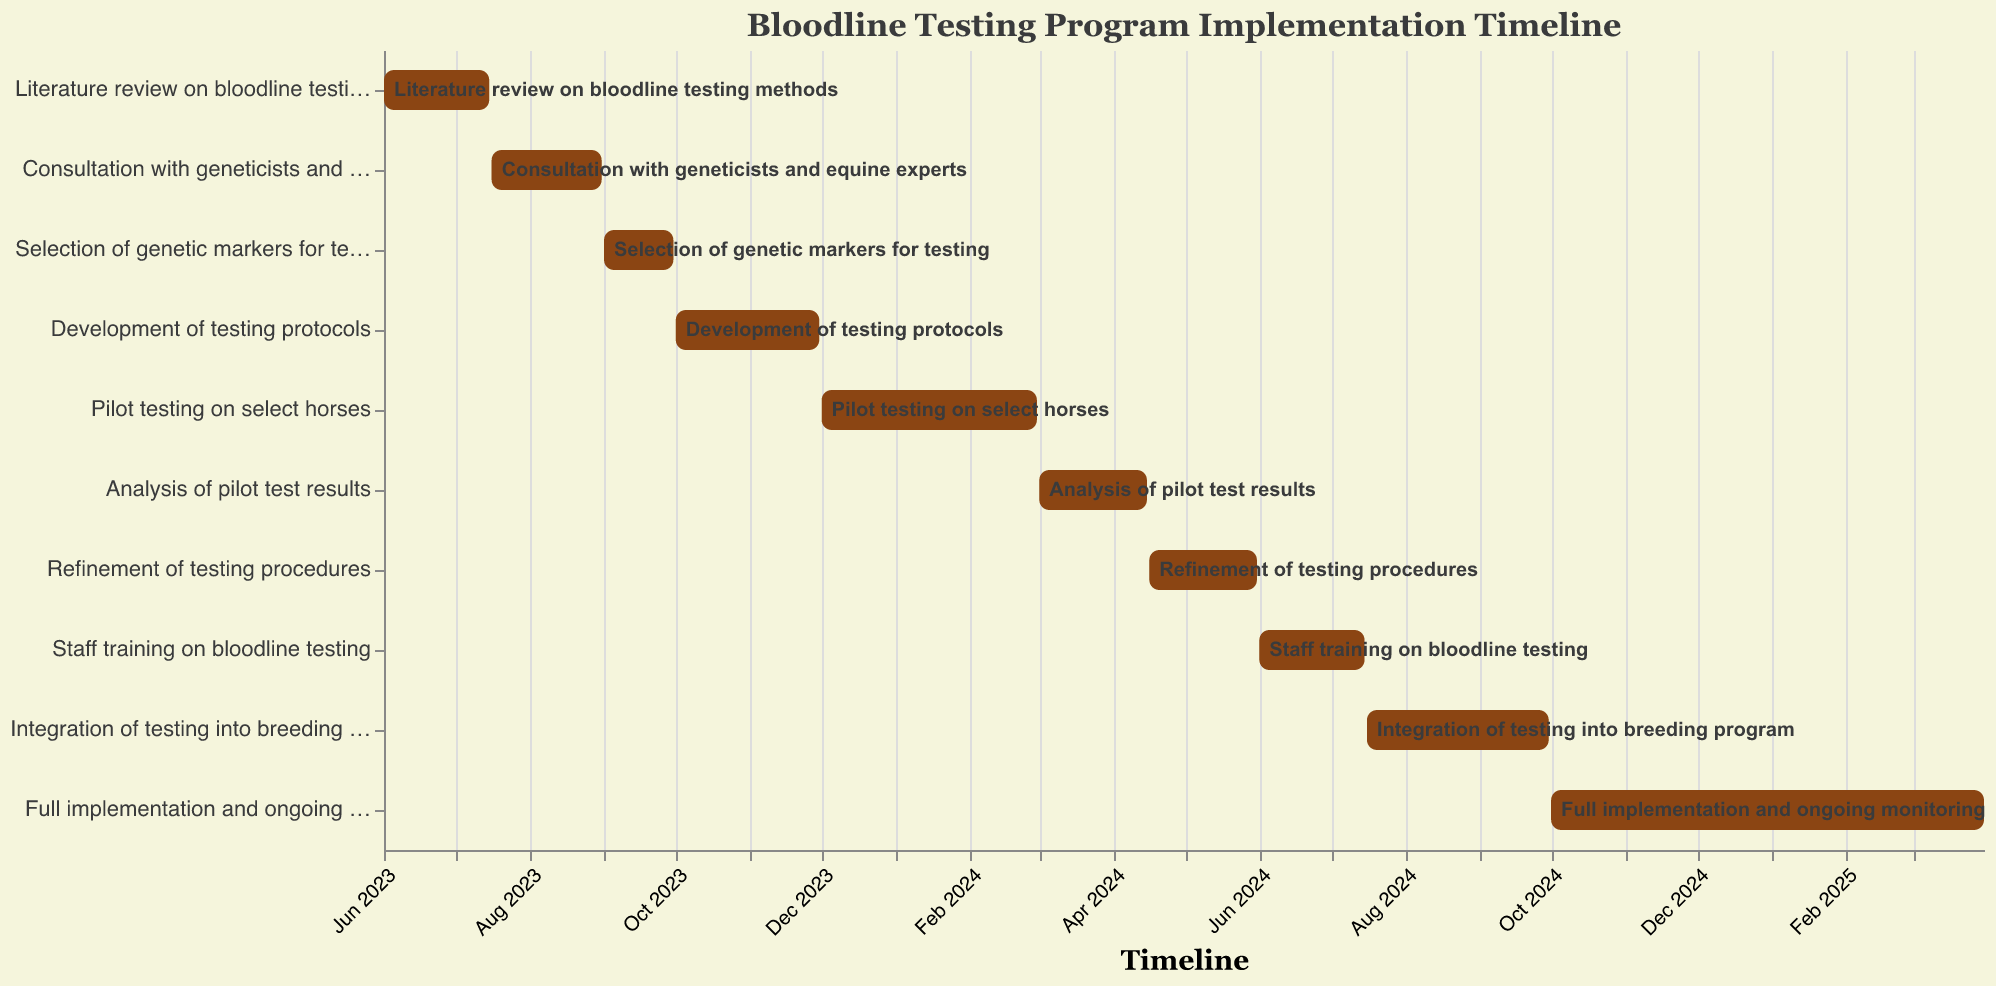What is the first task in the timeline? The first task can be identified as the task with the earliest start date. In the chart, "Literature review on bloodline testing methods" starts on 2023-06-01, which is the earliest date.
Answer: Literature review on bloodline testing methods When does the consultation with geneticists and equine experts end? To find the end date for this task, locate the "Consultation with geneticists and equine experts" bar and note the end date. According to the chart, this task ends on 2023-08-31.
Answer: 2023-08-31 How long is the pilot testing phase? To determine the duration of the pilot testing phase, find the start and end dates for "Pilot testing on select horses". The start date is 2023-12-01 and the end date is 2024-02-29. The duration is from December 1, 2023, to February 29, 2024, which includes December, January, and February. The total duration is 3 months.
Answer: 3 months Which task has the shortest duration? The shortest duration task is the one with the smallest difference between its start and end dates. "Selection of genetic markers for testing" runs from 2023-09-01 to 2023-09-30. This is a 30-day duration which appears to be the shortest in the timeline.
Answer: Selection of genetic markers for testing What tasks are scheduled to run concurrently with the development of testing protocols? To find concurrent tasks, identify the time period for "Development of testing protocols" which runs from 2023-10-01 to 2023-11-30, and look for other tasks that overlap with these dates. There are no tasks that start during this period or overlap significantly, so no other tasks run concurrently.
Answer: None How many tasks are planned for the year 2024? To count the tasks in 2024, look for tasks with start or end dates within 2024. The tasks are: "Pilot testing on select horses", "Analysis of pilot test results", "Refinement of testing procedures", "Staff training on bloodline testing", "Integration of testing into breeding program", and "Full implementation and ongoing monitoring". There are 6 tasks.
Answer: 6 When is the full implementation and ongoing monitoring phase scheduled to start and end? Find the bar labeled "Full implementation and ongoing monitoring". According to the chart, this task starts on 2024-10-01 and ends on 2025-03-31.
Answer: 2024-10-01 to 2025-03-31 Which task extends the furthest into 2025? To identify the task that extends the furthest, look at the end dates of tasks that continue into 2025. "Full implementation and ongoing monitoring" ends on 2025-03-31, making it the task that extends the furthest.
Answer: Full implementation and ongoing monitoring 